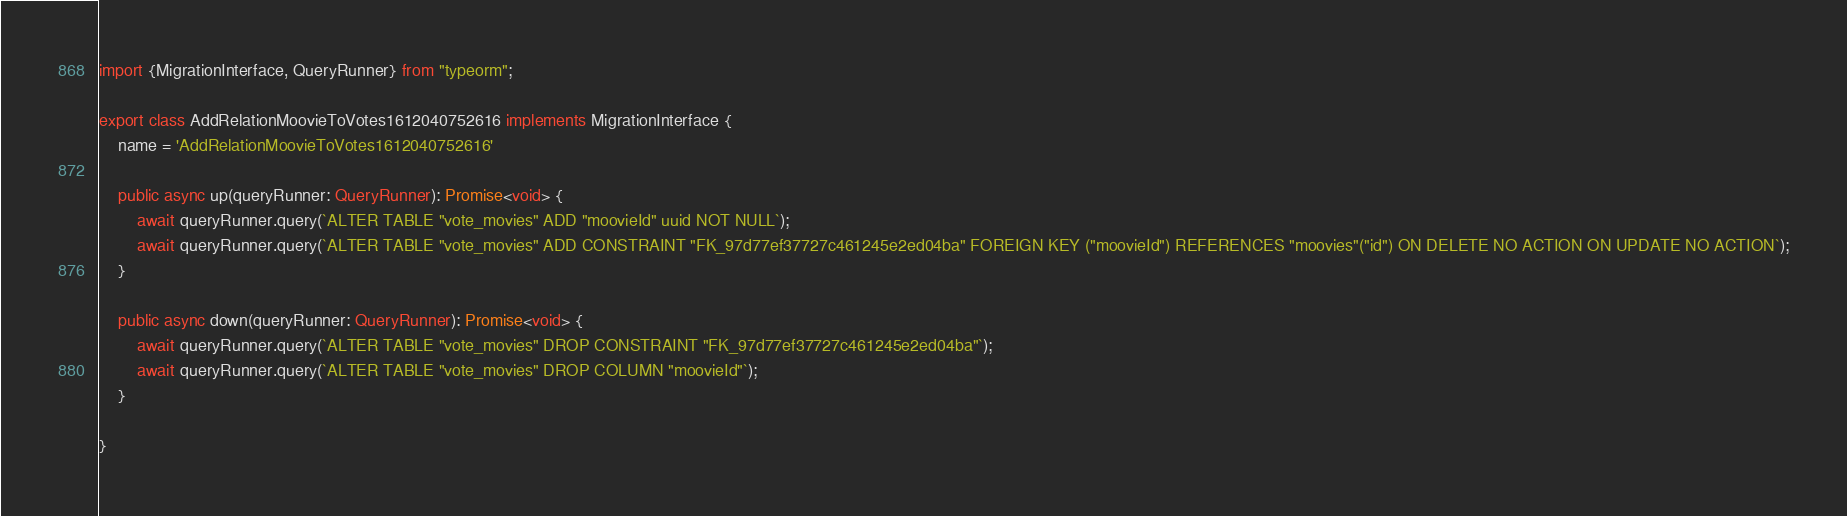Convert code to text. <code><loc_0><loc_0><loc_500><loc_500><_TypeScript_>import {MigrationInterface, QueryRunner} from "typeorm";

export class AddRelationMoovieToVotes1612040752616 implements MigrationInterface {
    name = 'AddRelationMoovieToVotes1612040752616'

    public async up(queryRunner: QueryRunner): Promise<void> {
        await queryRunner.query(`ALTER TABLE "vote_movies" ADD "moovieId" uuid NOT NULL`);
        await queryRunner.query(`ALTER TABLE "vote_movies" ADD CONSTRAINT "FK_97d77ef37727c461245e2ed04ba" FOREIGN KEY ("moovieId") REFERENCES "moovies"("id") ON DELETE NO ACTION ON UPDATE NO ACTION`);
    }

    public async down(queryRunner: QueryRunner): Promise<void> {
        await queryRunner.query(`ALTER TABLE "vote_movies" DROP CONSTRAINT "FK_97d77ef37727c461245e2ed04ba"`);
        await queryRunner.query(`ALTER TABLE "vote_movies" DROP COLUMN "moovieId"`);
    }

}
</code> 